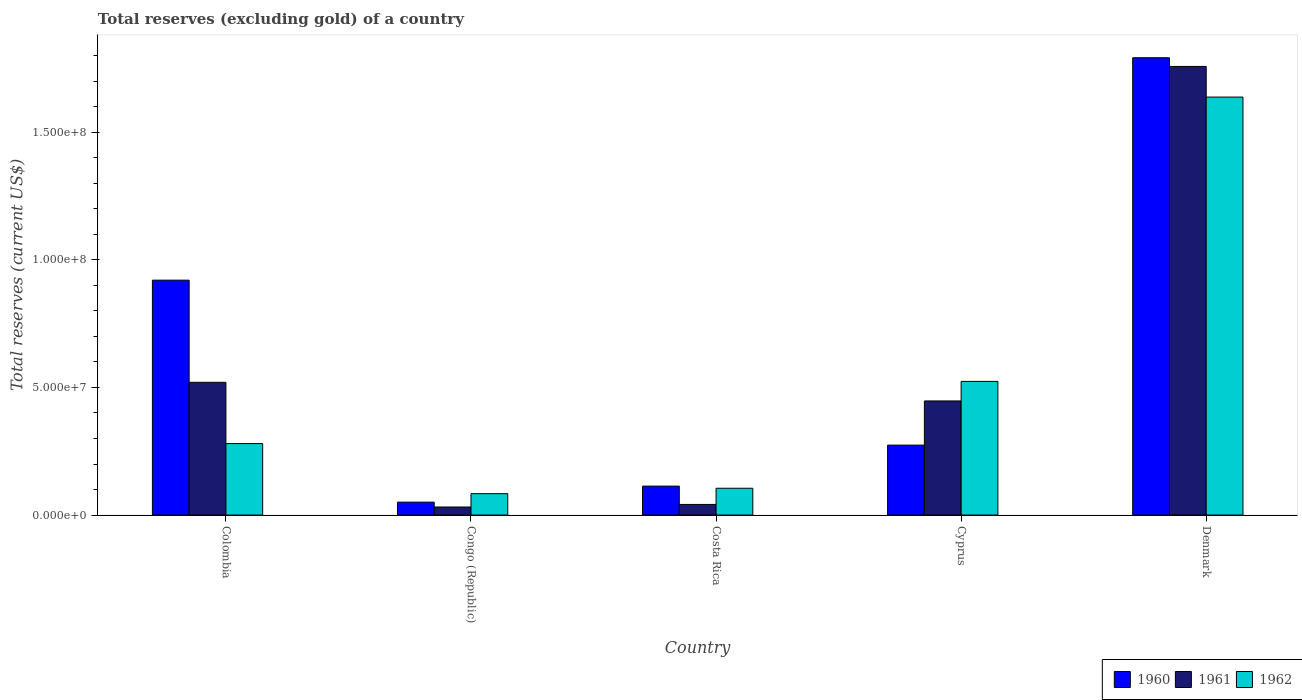How many different coloured bars are there?
Ensure brevity in your answer.  3. How many groups of bars are there?
Your answer should be very brief. 5. Are the number of bars per tick equal to the number of legend labels?
Make the answer very short. Yes. How many bars are there on the 3rd tick from the left?
Give a very brief answer. 3. What is the total reserves (excluding gold) in 1960 in Cyprus?
Keep it short and to the point. 2.74e+07. Across all countries, what is the maximum total reserves (excluding gold) in 1961?
Your response must be concise. 1.76e+08. Across all countries, what is the minimum total reserves (excluding gold) in 1960?
Keep it short and to the point. 5.06e+06. In which country was the total reserves (excluding gold) in 1960 maximum?
Your answer should be very brief. Denmark. In which country was the total reserves (excluding gold) in 1962 minimum?
Make the answer very short. Congo (Republic). What is the total total reserves (excluding gold) in 1961 in the graph?
Your response must be concise. 2.80e+08. What is the difference between the total reserves (excluding gold) in 1962 in Congo (Republic) and that in Cyprus?
Offer a terse response. -4.40e+07. What is the difference between the total reserves (excluding gold) in 1960 in Cyprus and the total reserves (excluding gold) in 1961 in Congo (Republic)?
Your answer should be very brief. 2.42e+07. What is the average total reserves (excluding gold) in 1960 per country?
Make the answer very short. 6.30e+07. What is the difference between the total reserves (excluding gold) of/in 1960 and total reserves (excluding gold) of/in 1961 in Costa Rica?
Your answer should be compact. 7.17e+06. In how many countries, is the total reserves (excluding gold) in 1962 greater than 80000000 US$?
Offer a very short reply. 1. What is the ratio of the total reserves (excluding gold) in 1961 in Colombia to that in Cyprus?
Make the answer very short. 1.16. Is the total reserves (excluding gold) in 1960 in Cyprus less than that in Denmark?
Provide a succinct answer. Yes. Is the difference between the total reserves (excluding gold) in 1960 in Congo (Republic) and Costa Rica greater than the difference between the total reserves (excluding gold) in 1961 in Congo (Republic) and Costa Rica?
Your answer should be compact. No. What is the difference between the highest and the second highest total reserves (excluding gold) in 1960?
Your response must be concise. -6.46e+07. What is the difference between the highest and the lowest total reserves (excluding gold) in 1961?
Provide a succinct answer. 1.73e+08. In how many countries, is the total reserves (excluding gold) in 1961 greater than the average total reserves (excluding gold) in 1961 taken over all countries?
Offer a very short reply. 1. What does the 2nd bar from the right in Denmark represents?
Your answer should be compact. 1961. Is it the case that in every country, the sum of the total reserves (excluding gold) in 1960 and total reserves (excluding gold) in 1961 is greater than the total reserves (excluding gold) in 1962?
Give a very brief answer. No. How many bars are there?
Offer a very short reply. 15. Are all the bars in the graph horizontal?
Ensure brevity in your answer.  No. How many countries are there in the graph?
Your answer should be very brief. 5. What is the difference between two consecutive major ticks on the Y-axis?
Make the answer very short. 5.00e+07. Where does the legend appear in the graph?
Keep it short and to the point. Bottom right. What is the title of the graph?
Your response must be concise. Total reserves (excluding gold) of a country. Does "2005" appear as one of the legend labels in the graph?
Your response must be concise. No. What is the label or title of the Y-axis?
Provide a short and direct response. Total reserves (current US$). What is the Total reserves (current US$) of 1960 in Colombia?
Make the answer very short. 9.20e+07. What is the Total reserves (current US$) in 1961 in Colombia?
Your response must be concise. 5.20e+07. What is the Total reserves (current US$) of 1962 in Colombia?
Provide a short and direct response. 2.80e+07. What is the Total reserves (current US$) in 1960 in Congo (Republic)?
Provide a short and direct response. 5.06e+06. What is the Total reserves (current US$) of 1961 in Congo (Republic)?
Offer a very short reply. 3.16e+06. What is the Total reserves (current US$) of 1962 in Congo (Republic)?
Give a very brief answer. 8.38e+06. What is the Total reserves (current US$) in 1960 in Costa Rica?
Keep it short and to the point. 1.13e+07. What is the Total reserves (current US$) of 1961 in Costa Rica?
Your response must be concise. 4.17e+06. What is the Total reserves (current US$) of 1962 in Costa Rica?
Offer a very short reply. 1.05e+07. What is the Total reserves (current US$) of 1960 in Cyprus?
Keep it short and to the point. 2.74e+07. What is the Total reserves (current US$) of 1961 in Cyprus?
Offer a terse response. 4.47e+07. What is the Total reserves (current US$) in 1962 in Cyprus?
Give a very brief answer. 5.23e+07. What is the Total reserves (current US$) of 1960 in Denmark?
Keep it short and to the point. 1.79e+08. What is the Total reserves (current US$) of 1961 in Denmark?
Ensure brevity in your answer.  1.76e+08. What is the Total reserves (current US$) of 1962 in Denmark?
Your response must be concise. 1.64e+08. Across all countries, what is the maximum Total reserves (current US$) of 1960?
Your response must be concise. 1.79e+08. Across all countries, what is the maximum Total reserves (current US$) of 1961?
Make the answer very short. 1.76e+08. Across all countries, what is the maximum Total reserves (current US$) in 1962?
Offer a terse response. 1.64e+08. Across all countries, what is the minimum Total reserves (current US$) in 1960?
Provide a short and direct response. 5.06e+06. Across all countries, what is the minimum Total reserves (current US$) in 1961?
Ensure brevity in your answer.  3.16e+06. Across all countries, what is the minimum Total reserves (current US$) in 1962?
Keep it short and to the point. 8.38e+06. What is the total Total reserves (current US$) of 1960 in the graph?
Give a very brief answer. 3.15e+08. What is the total Total reserves (current US$) of 1961 in the graph?
Your answer should be very brief. 2.80e+08. What is the total Total reserves (current US$) in 1962 in the graph?
Your answer should be very brief. 2.63e+08. What is the difference between the Total reserves (current US$) in 1960 in Colombia and that in Congo (Republic)?
Give a very brief answer. 8.69e+07. What is the difference between the Total reserves (current US$) in 1961 in Colombia and that in Congo (Republic)?
Offer a terse response. 4.88e+07. What is the difference between the Total reserves (current US$) of 1962 in Colombia and that in Congo (Republic)?
Your response must be concise. 1.96e+07. What is the difference between the Total reserves (current US$) in 1960 in Colombia and that in Costa Rica?
Provide a short and direct response. 8.07e+07. What is the difference between the Total reserves (current US$) of 1961 in Colombia and that in Costa Rica?
Provide a succinct answer. 4.78e+07. What is the difference between the Total reserves (current US$) in 1962 in Colombia and that in Costa Rica?
Give a very brief answer. 1.75e+07. What is the difference between the Total reserves (current US$) in 1960 in Colombia and that in Cyprus?
Provide a succinct answer. 6.46e+07. What is the difference between the Total reserves (current US$) of 1961 in Colombia and that in Cyprus?
Keep it short and to the point. 7.30e+06. What is the difference between the Total reserves (current US$) in 1962 in Colombia and that in Cyprus?
Your response must be concise. -2.43e+07. What is the difference between the Total reserves (current US$) in 1960 in Colombia and that in Denmark?
Your response must be concise. -8.71e+07. What is the difference between the Total reserves (current US$) of 1961 in Colombia and that in Denmark?
Keep it short and to the point. -1.24e+08. What is the difference between the Total reserves (current US$) of 1962 in Colombia and that in Denmark?
Offer a very short reply. -1.36e+08. What is the difference between the Total reserves (current US$) in 1960 in Congo (Republic) and that in Costa Rica?
Your answer should be very brief. -6.28e+06. What is the difference between the Total reserves (current US$) in 1961 in Congo (Republic) and that in Costa Rica?
Your answer should be very brief. -1.01e+06. What is the difference between the Total reserves (current US$) in 1962 in Congo (Republic) and that in Costa Rica?
Give a very brief answer. -2.13e+06. What is the difference between the Total reserves (current US$) in 1960 in Congo (Republic) and that in Cyprus?
Your response must be concise. -2.23e+07. What is the difference between the Total reserves (current US$) in 1961 in Congo (Republic) and that in Cyprus?
Keep it short and to the point. -4.15e+07. What is the difference between the Total reserves (current US$) in 1962 in Congo (Republic) and that in Cyprus?
Your answer should be very brief. -4.40e+07. What is the difference between the Total reserves (current US$) of 1960 in Congo (Republic) and that in Denmark?
Ensure brevity in your answer.  -1.74e+08. What is the difference between the Total reserves (current US$) in 1961 in Congo (Republic) and that in Denmark?
Your answer should be very brief. -1.73e+08. What is the difference between the Total reserves (current US$) in 1962 in Congo (Republic) and that in Denmark?
Provide a succinct answer. -1.55e+08. What is the difference between the Total reserves (current US$) of 1960 in Costa Rica and that in Cyprus?
Keep it short and to the point. -1.61e+07. What is the difference between the Total reserves (current US$) of 1961 in Costa Rica and that in Cyprus?
Ensure brevity in your answer.  -4.05e+07. What is the difference between the Total reserves (current US$) of 1962 in Costa Rica and that in Cyprus?
Your response must be concise. -4.18e+07. What is the difference between the Total reserves (current US$) in 1960 in Costa Rica and that in Denmark?
Provide a succinct answer. -1.68e+08. What is the difference between the Total reserves (current US$) of 1961 in Costa Rica and that in Denmark?
Make the answer very short. -1.72e+08. What is the difference between the Total reserves (current US$) of 1962 in Costa Rica and that in Denmark?
Keep it short and to the point. -1.53e+08. What is the difference between the Total reserves (current US$) of 1960 in Cyprus and that in Denmark?
Give a very brief answer. -1.52e+08. What is the difference between the Total reserves (current US$) of 1961 in Cyprus and that in Denmark?
Keep it short and to the point. -1.31e+08. What is the difference between the Total reserves (current US$) of 1962 in Cyprus and that in Denmark?
Keep it short and to the point. -1.11e+08. What is the difference between the Total reserves (current US$) of 1960 in Colombia and the Total reserves (current US$) of 1961 in Congo (Republic)?
Keep it short and to the point. 8.88e+07. What is the difference between the Total reserves (current US$) of 1960 in Colombia and the Total reserves (current US$) of 1962 in Congo (Republic)?
Your response must be concise. 8.36e+07. What is the difference between the Total reserves (current US$) in 1961 in Colombia and the Total reserves (current US$) in 1962 in Congo (Republic)?
Give a very brief answer. 4.36e+07. What is the difference between the Total reserves (current US$) in 1960 in Colombia and the Total reserves (current US$) in 1961 in Costa Rica?
Your answer should be compact. 8.78e+07. What is the difference between the Total reserves (current US$) of 1960 in Colombia and the Total reserves (current US$) of 1962 in Costa Rica?
Offer a very short reply. 8.15e+07. What is the difference between the Total reserves (current US$) in 1961 in Colombia and the Total reserves (current US$) in 1962 in Costa Rica?
Ensure brevity in your answer.  4.15e+07. What is the difference between the Total reserves (current US$) in 1960 in Colombia and the Total reserves (current US$) in 1961 in Cyprus?
Your answer should be very brief. 4.73e+07. What is the difference between the Total reserves (current US$) of 1960 in Colombia and the Total reserves (current US$) of 1962 in Cyprus?
Offer a very short reply. 3.96e+07. What is the difference between the Total reserves (current US$) in 1961 in Colombia and the Total reserves (current US$) in 1962 in Cyprus?
Make the answer very short. -3.50e+05. What is the difference between the Total reserves (current US$) in 1960 in Colombia and the Total reserves (current US$) in 1961 in Denmark?
Provide a short and direct response. -8.37e+07. What is the difference between the Total reserves (current US$) of 1960 in Colombia and the Total reserves (current US$) of 1962 in Denmark?
Offer a terse response. -7.17e+07. What is the difference between the Total reserves (current US$) in 1961 in Colombia and the Total reserves (current US$) in 1962 in Denmark?
Provide a succinct answer. -1.12e+08. What is the difference between the Total reserves (current US$) of 1960 in Congo (Republic) and the Total reserves (current US$) of 1961 in Costa Rica?
Provide a succinct answer. 8.90e+05. What is the difference between the Total reserves (current US$) in 1960 in Congo (Republic) and the Total reserves (current US$) in 1962 in Costa Rica?
Your answer should be very brief. -5.45e+06. What is the difference between the Total reserves (current US$) of 1961 in Congo (Republic) and the Total reserves (current US$) of 1962 in Costa Rica?
Your answer should be very brief. -7.35e+06. What is the difference between the Total reserves (current US$) in 1960 in Congo (Republic) and the Total reserves (current US$) in 1961 in Cyprus?
Your answer should be compact. -3.96e+07. What is the difference between the Total reserves (current US$) in 1960 in Congo (Republic) and the Total reserves (current US$) in 1962 in Cyprus?
Keep it short and to the point. -4.73e+07. What is the difference between the Total reserves (current US$) of 1961 in Congo (Republic) and the Total reserves (current US$) of 1962 in Cyprus?
Offer a terse response. -4.92e+07. What is the difference between the Total reserves (current US$) of 1960 in Congo (Republic) and the Total reserves (current US$) of 1961 in Denmark?
Make the answer very short. -1.71e+08. What is the difference between the Total reserves (current US$) in 1960 in Congo (Republic) and the Total reserves (current US$) in 1962 in Denmark?
Give a very brief answer. -1.59e+08. What is the difference between the Total reserves (current US$) of 1961 in Congo (Republic) and the Total reserves (current US$) of 1962 in Denmark?
Make the answer very short. -1.61e+08. What is the difference between the Total reserves (current US$) in 1960 in Costa Rica and the Total reserves (current US$) in 1961 in Cyprus?
Your answer should be very brief. -3.34e+07. What is the difference between the Total reserves (current US$) in 1960 in Costa Rica and the Total reserves (current US$) in 1962 in Cyprus?
Your answer should be compact. -4.10e+07. What is the difference between the Total reserves (current US$) in 1961 in Costa Rica and the Total reserves (current US$) in 1962 in Cyprus?
Your answer should be compact. -4.82e+07. What is the difference between the Total reserves (current US$) of 1960 in Costa Rica and the Total reserves (current US$) of 1961 in Denmark?
Your response must be concise. -1.64e+08. What is the difference between the Total reserves (current US$) in 1960 in Costa Rica and the Total reserves (current US$) in 1962 in Denmark?
Your answer should be compact. -1.52e+08. What is the difference between the Total reserves (current US$) in 1961 in Costa Rica and the Total reserves (current US$) in 1962 in Denmark?
Provide a succinct answer. -1.60e+08. What is the difference between the Total reserves (current US$) of 1960 in Cyprus and the Total reserves (current US$) of 1961 in Denmark?
Provide a short and direct response. -1.48e+08. What is the difference between the Total reserves (current US$) of 1960 in Cyprus and the Total reserves (current US$) of 1962 in Denmark?
Your answer should be very brief. -1.36e+08. What is the difference between the Total reserves (current US$) in 1961 in Cyprus and the Total reserves (current US$) in 1962 in Denmark?
Offer a terse response. -1.19e+08. What is the average Total reserves (current US$) of 1960 per country?
Offer a very short reply. 6.30e+07. What is the average Total reserves (current US$) in 1961 per country?
Your answer should be very brief. 5.59e+07. What is the average Total reserves (current US$) of 1962 per country?
Give a very brief answer. 5.26e+07. What is the difference between the Total reserves (current US$) in 1960 and Total reserves (current US$) in 1961 in Colombia?
Make the answer very short. 4.00e+07. What is the difference between the Total reserves (current US$) in 1960 and Total reserves (current US$) in 1962 in Colombia?
Provide a succinct answer. 6.40e+07. What is the difference between the Total reserves (current US$) in 1961 and Total reserves (current US$) in 1962 in Colombia?
Provide a succinct answer. 2.40e+07. What is the difference between the Total reserves (current US$) in 1960 and Total reserves (current US$) in 1961 in Congo (Republic)?
Provide a short and direct response. 1.90e+06. What is the difference between the Total reserves (current US$) of 1960 and Total reserves (current US$) of 1962 in Congo (Republic)?
Offer a terse response. -3.32e+06. What is the difference between the Total reserves (current US$) of 1961 and Total reserves (current US$) of 1962 in Congo (Republic)?
Your answer should be compact. -5.22e+06. What is the difference between the Total reserves (current US$) in 1960 and Total reserves (current US$) in 1961 in Costa Rica?
Your answer should be very brief. 7.17e+06. What is the difference between the Total reserves (current US$) of 1960 and Total reserves (current US$) of 1962 in Costa Rica?
Your answer should be compact. 8.30e+05. What is the difference between the Total reserves (current US$) of 1961 and Total reserves (current US$) of 1962 in Costa Rica?
Make the answer very short. -6.34e+06. What is the difference between the Total reserves (current US$) in 1960 and Total reserves (current US$) in 1961 in Cyprus?
Provide a succinct answer. -1.73e+07. What is the difference between the Total reserves (current US$) of 1960 and Total reserves (current US$) of 1962 in Cyprus?
Offer a very short reply. -2.49e+07. What is the difference between the Total reserves (current US$) of 1961 and Total reserves (current US$) of 1962 in Cyprus?
Offer a terse response. -7.65e+06. What is the difference between the Total reserves (current US$) in 1960 and Total reserves (current US$) in 1961 in Denmark?
Provide a succinct answer. 3.40e+06. What is the difference between the Total reserves (current US$) in 1960 and Total reserves (current US$) in 1962 in Denmark?
Your response must be concise. 1.54e+07. What is the ratio of the Total reserves (current US$) in 1960 in Colombia to that in Congo (Republic)?
Provide a short and direct response. 18.18. What is the ratio of the Total reserves (current US$) in 1961 in Colombia to that in Congo (Republic)?
Offer a terse response. 16.46. What is the ratio of the Total reserves (current US$) of 1962 in Colombia to that in Congo (Republic)?
Offer a terse response. 3.34. What is the ratio of the Total reserves (current US$) in 1960 in Colombia to that in Costa Rica?
Keep it short and to the point. 8.11. What is the ratio of the Total reserves (current US$) in 1961 in Colombia to that in Costa Rica?
Offer a very short reply. 12.47. What is the ratio of the Total reserves (current US$) in 1962 in Colombia to that in Costa Rica?
Offer a very short reply. 2.66. What is the ratio of the Total reserves (current US$) of 1960 in Colombia to that in Cyprus?
Your response must be concise. 3.36. What is the ratio of the Total reserves (current US$) in 1961 in Colombia to that in Cyprus?
Your answer should be compact. 1.16. What is the ratio of the Total reserves (current US$) of 1962 in Colombia to that in Cyprus?
Your answer should be compact. 0.53. What is the ratio of the Total reserves (current US$) of 1960 in Colombia to that in Denmark?
Make the answer very short. 0.51. What is the ratio of the Total reserves (current US$) in 1961 in Colombia to that in Denmark?
Keep it short and to the point. 0.3. What is the ratio of the Total reserves (current US$) in 1962 in Colombia to that in Denmark?
Offer a very short reply. 0.17. What is the ratio of the Total reserves (current US$) of 1960 in Congo (Republic) to that in Costa Rica?
Offer a terse response. 0.45. What is the ratio of the Total reserves (current US$) of 1961 in Congo (Republic) to that in Costa Rica?
Provide a short and direct response. 0.76. What is the ratio of the Total reserves (current US$) of 1962 in Congo (Republic) to that in Costa Rica?
Your response must be concise. 0.8. What is the ratio of the Total reserves (current US$) of 1960 in Congo (Republic) to that in Cyprus?
Your response must be concise. 0.18. What is the ratio of the Total reserves (current US$) in 1961 in Congo (Republic) to that in Cyprus?
Offer a very short reply. 0.07. What is the ratio of the Total reserves (current US$) in 1962 in Congo (Republic) to that in Cyprus?
Keep it short and to the point. 0.16. What is the ratio of the Total reserves (current US$) of 1960 in Congo (Republic) to that in Denmark?
Your answer should be compact. 0.03. What is the ratio of the Total reserves (current US$) in 1961 in Congo (Republic) to that in Denmark?
Keep it short and to the point. 0.02. What is the ratio of the Total reserves (current US$) in 1962 in Congo (Republic) to that in Denmark?
Offer a very short reply. 0.05. What is the ratio of the Total reserves (current US$) of 1960 in Costa Rica to that in Cyprus?
Ensure brevity in your answer.  0.41. What is the ratio of the Total reserves (current US$) in 1961 in Costa Rica to that in Cyprus?
Your response must be concise. 0.09. What is the ratio of the Total reserves (current US$) of 1962 in Costa Rica to that in Cyprus?
Give a very brief answer. 0.2. What is the ratio of the Total reserves (current US$) in 1960 in Costa Rica to that in Denmark?
Provide a succinct answer. 0.06. What is the ratio of the Total reserves (current US$) in 1961 in Costa Rica to that in Denmark?
Give a very brief answer. 0.02. What is the ratio of the Total reserves (current US$) in 1962 in Costa Rica to that in Denmark?
Provide a short and direct response. 0.06. What is the ratio of the Total reserves (current US$) in 1960 in Cyprus to that in Denmark?
Ensure brevity in your answer.  0.15. What is the ratio of the Total reserves (current US$) of 1961 in Cyprus to that in Denmark?
Offer a terse response. 0.25. What is the ratio of the Total reserves (current US$) of 1962 in Cyprus to that in Denmark?
Provide a succinct answer. 0.32. What is the difference between the highest and the second highest Total reserves (current US$) of 1960?
Offer a very short reply. 8.71e+07. What is the difference between the highest and the second highest Total reserves (current US$) in 1961?
Give a very brief answer. 1.24e+08. What is the difference between the highest and the second highest Total reserves (current US$) of 1962?
Give a very brief answer. 1.11e+08. What is the difference between the highest and the lowest Total reserves (current US$) of 1960?
Your response must be concise. 1.74e+08. What is the difference between the highest and the lowest Total reserves (current US$) of 1961?
Offer a very short reply. 1.73e+08. What is the difference between the highest and the lowest Total reserves (current US$) in 1962?
Your answer should be very brief. 1.55e+08. 